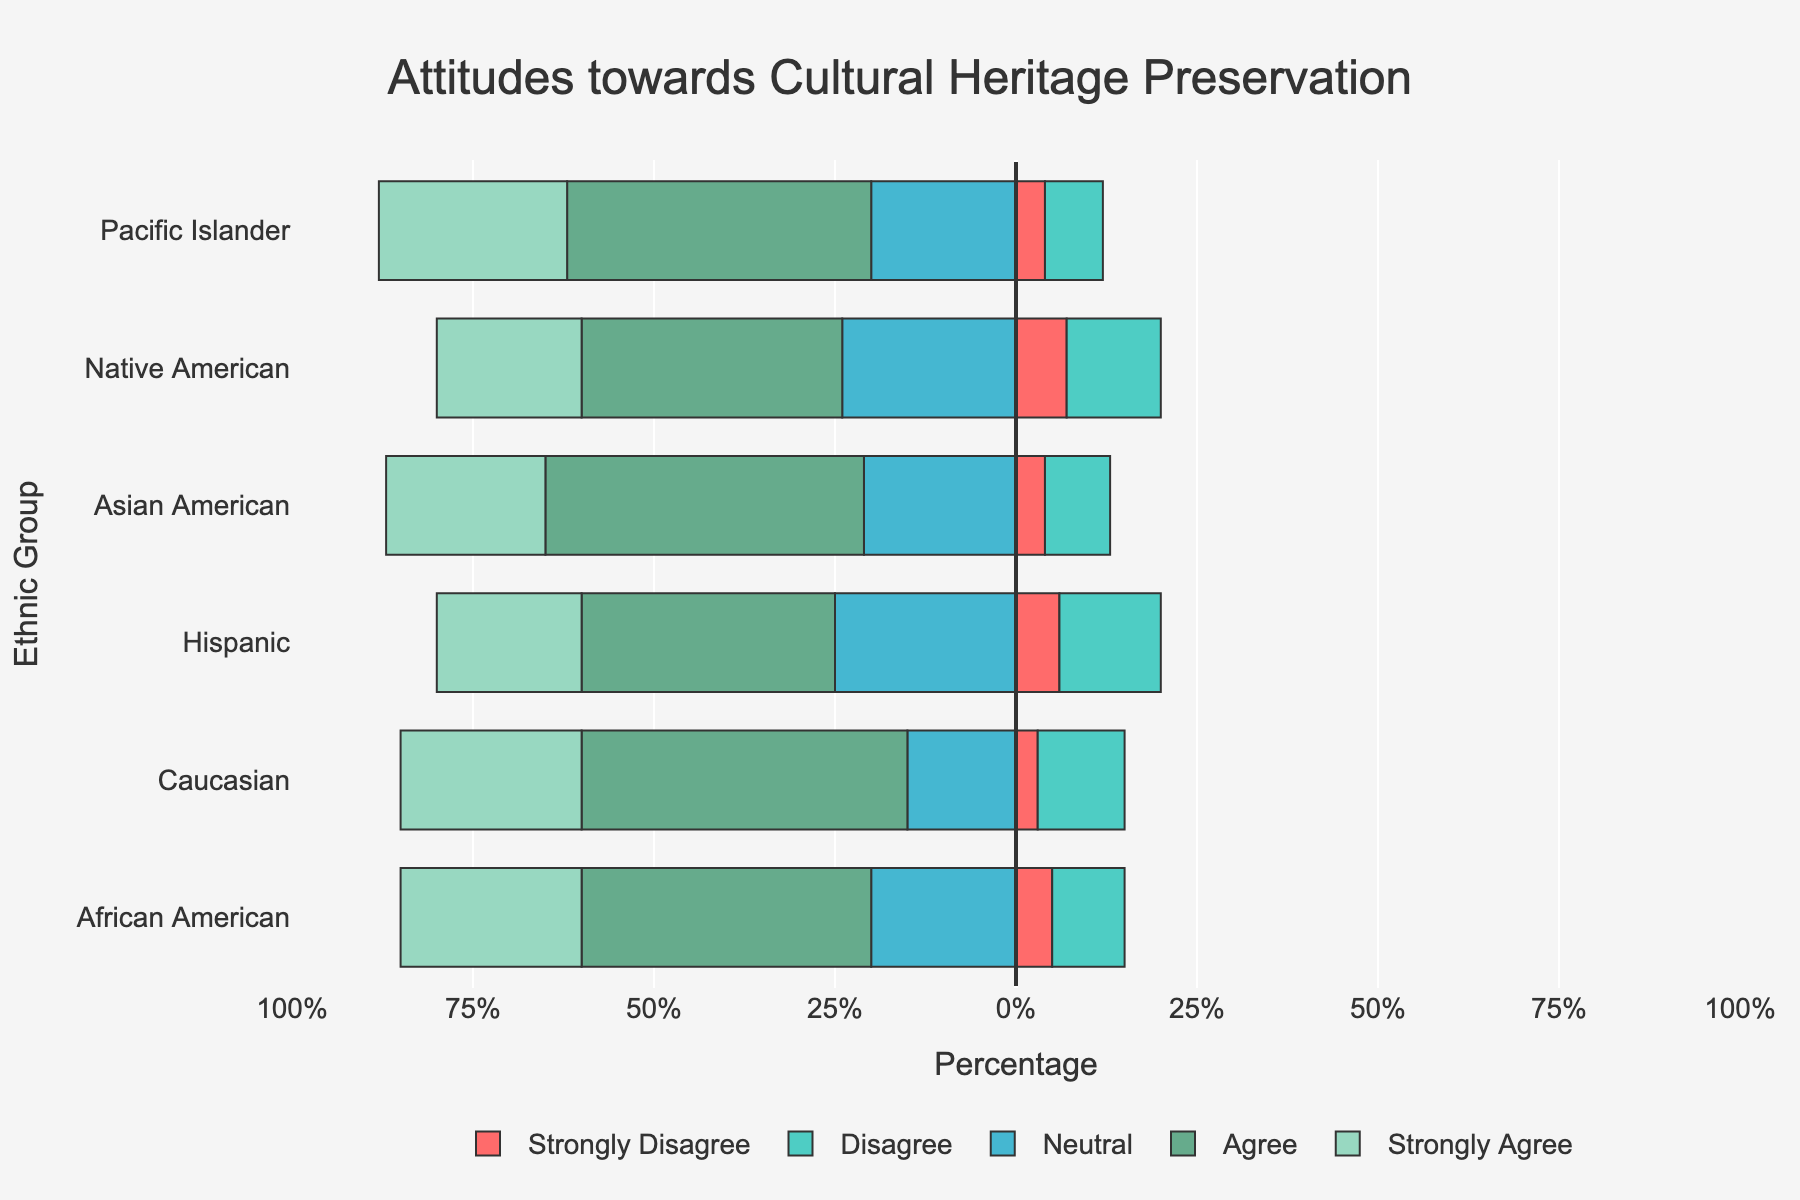What's the difference in the percentage of people who 'Strongly Agree' with cultural heritage preservation between Caucasians and African Americans? For Caucasians, 'Strongly Agree' is 25%. For African Americans, it is also 25%. The difference is 25% - 25% = 0%.
Answer: 0% Which ethnic group has the highest percentage of 'Agree' responses? By visually inspecting the length of the green bars representing 'Agree' responses, we see that Caucasians have the longest bar at 45%, the highest among all ethnic groups.
Answer: Caucasian What's the total percentage of respondents who 'Agree' or 'Strongly Agree' among Native Americans? For Native Americans, 'Agree' is 36% and 'Strongly Agree' is 20%. The total is 36% + 20% = 56%.
Answer: 56% Compare the 'Disagree' responses between Asian Americans and Pacific Islanders. Who disagrees more? 'Disagree' responses for Asian Americans are 9%, while for Pacific Islanders, it is 8%. Asian Americans have a higher percentage of disagreements.
Answer: Asian Americans For the Hispanic ethnic group, what is the sum of the percentages for 'Strongly Disagree' and 'Disagree'? 'Strongly Disagree' for Hispanics is 6% and 'Disagree' is 14%. The sum is 6% + 14% = 20%.
Answer: 20% Which ethnic group has the smallest percentage of 'Neutral' responses? The 'Neutral' responses are color-coded and visually inspecting the shortest bar for 'Neutral', which is 15% for Caucasians, the smallest among all groups.
Answer: Caucasian How does the combined percentage of 'Neutral' and 'Strongly Agree' responses of African Americans compare to that of Hispanic respondents? For African Americans, 'Neutral' is 20% and 'Strongly Agree' is 25%, so combined it is 20% + 25% = 45%. For Hispanics, 'Neutral' is 25% and 'Strongly Agree' is 20%, so combined it is 25% + 20% = 45%. Both are the same at 45%.
Answer: 45% for both Among all ethnic groups, which has the highest total percentage of 'Strongly Disagree', 'Disagree', and 'Neutral' responses? Sum 'Strongly Disagree', 'Disagree', and 'Neutral' for each ethnic group: 
- African American: 5% + 10% + 20% = 35%
- Caucasian: 3% + 12% + 15% = 30%
- Hispanic: 6% + 14% + 25% = 45%
- Asian American: 4% + 9% + 21% = 34%
- Native American: 7% + 13% + 24% = 44%
- Pacific Islander: 4% + 8% + 20% = 32%
Hispanics have the highest with 45%.
Answer: Hispanic 